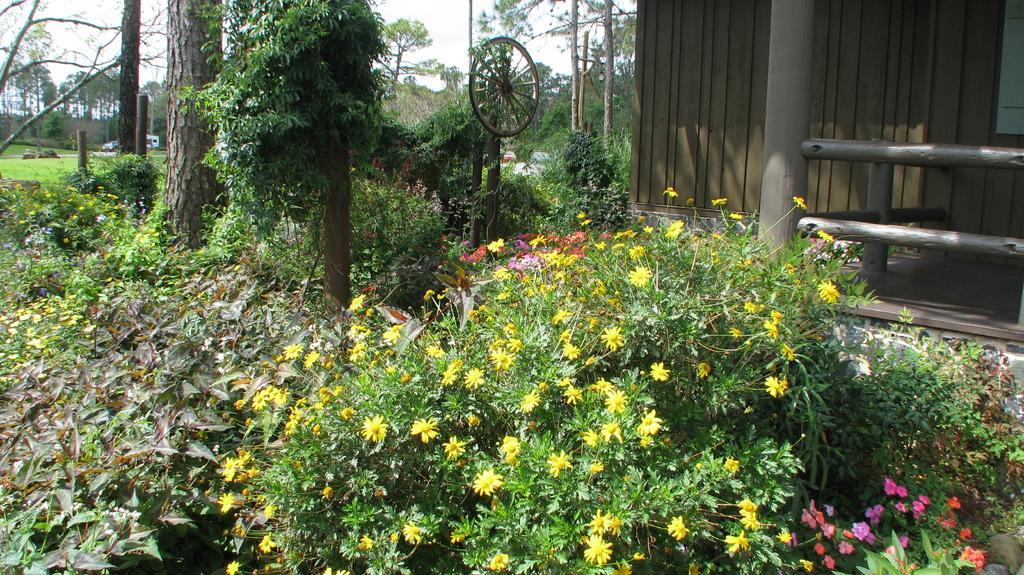In one or two sentences, can you explain what this image depicts? In the center of the image we can see trees,plants and flowers,which are in different colors. In the background we can see the sky,clouds,trees,plants,grass,vehicles,poles,one wooden house,one wheel,fence etc. 